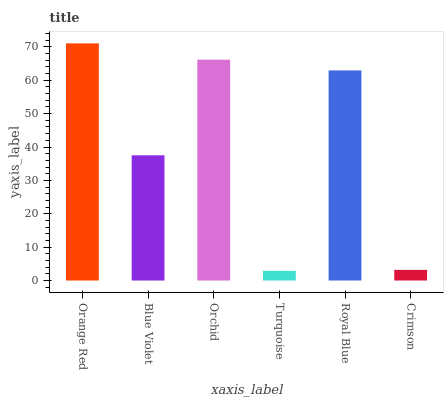Is Blue Violet the minimum?
Answer yes or no. No. Is Blue Violet the maximum?
Answer yes or no. No. Is Orange Red greater than Blue Violet?
Answer yes or no. Yes. Is Blue Violet less than Orange Red?
Answer yes or no. Yes. Is Blue Violet greater than Orange Red?
Answer yes or no. No. Is Orange Red less than Blue Violet?
Answer yes or no. No. Is Royal Blue the high median?
Answer yes or no. Yes. Is Blue Violet the low median?
Answer yes or no. Yes. Is Turquoise the high median?
Answer yes or no. No. Is Orchid the low median?
Answer yes or no. No. 